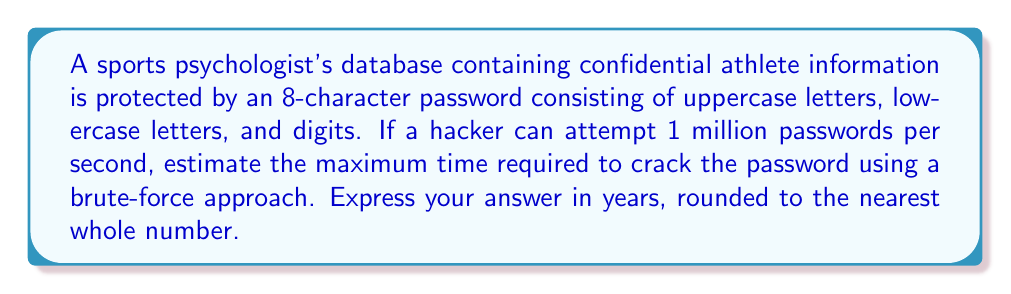Can you solve this math problem? To solve this problem, we need to follow these steps:

1. Calculate the total number of possible passwords:
   - Uppercase letters: 26
   - Lowercase letters: 26
   - Digits: 10
   - Total characters: 26 + 26 + 10 = 62
   - Password length: 8
   - Total combinations: $62^8$

2. Calculate the time required to try all combinations:
   Let $T$ be the time in seconds.
   $$T = \frac{62^8}{10^6}$$

3. Convert seconds to years:
   - Seconds in a year: 365 * 24 * 60 * 60 = 31,536,000
   - Years = $\frac{T}{31,536,000}$

4. Perform the calculation:
   $$\text{Years} = \frac{62^8}{10^6 \times 31,536,000}$$
   $$= \frac{218,340,105,584,896}{31,536,000}$$
   $$\approx 6,923.8$$

5. Round to the nearest whole number:
   6,924 years
Answer: 6,924 years 